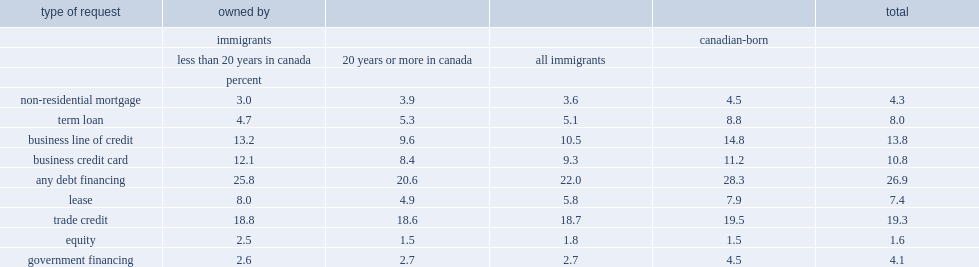What percent of firms with canadian-born owners applies for any debt financing? 28.3. What percent of firms with immigrant owners sought any forms of financing? 22.0. Which type of owners generally turn to formal financial institutions for debt financing less often? immigrant owners or canadian-born owners? All immigrants. Which type of owners turned to financing from government lending institutions less often ? immigrant owners or canadian-born owners? All immigrants. What percent of the firms with canadian-born and immigrant owners tended seek a trade credit, respectively? 18.7 19.5. Which type of request was rarely sought by smes with either immigrant or canadian-born owners? Equity. 